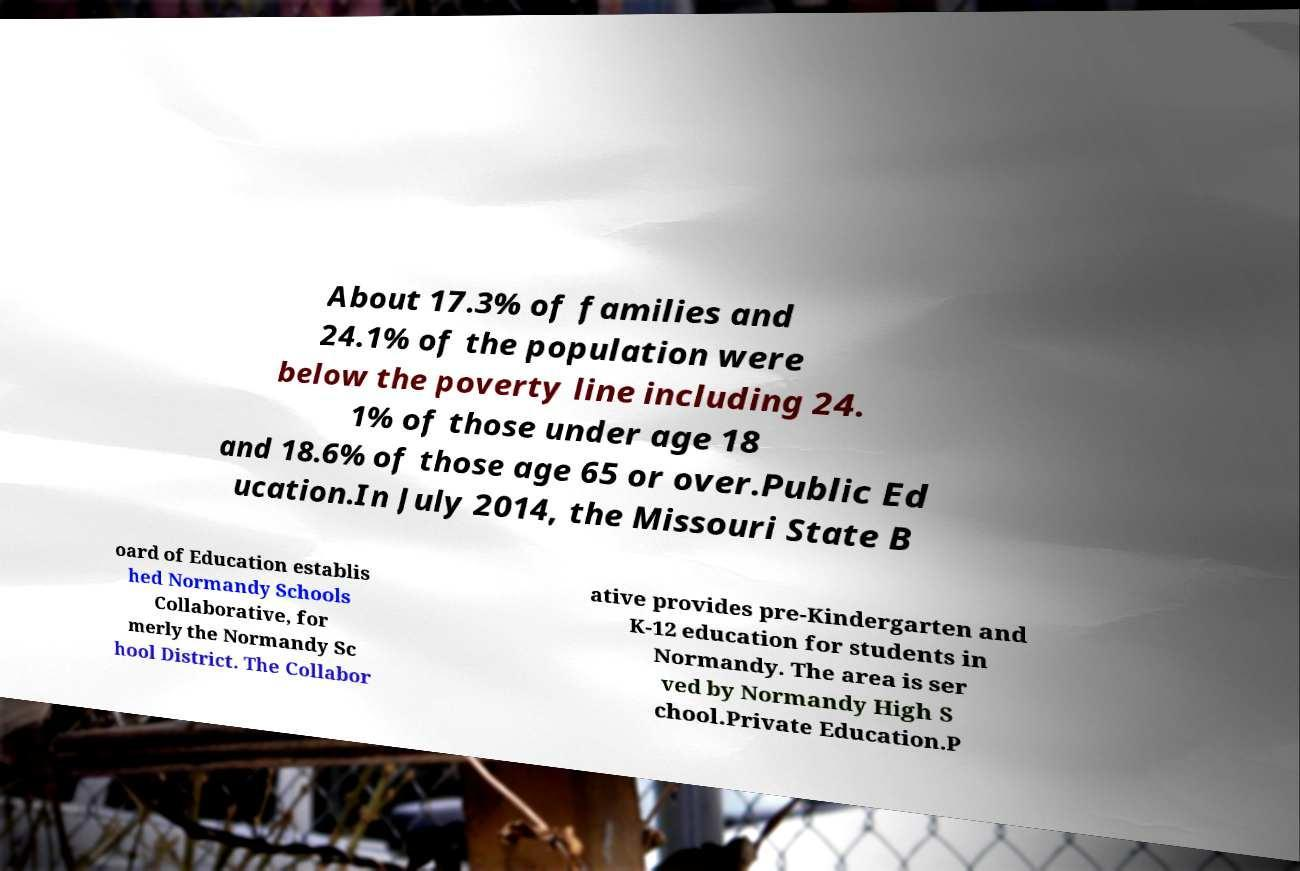What messages or text are displayed in this image? I need them in a readable, typed format. About 17.3% of families and 24.1% of the population were below the poverty line including 24. 1% of those under age 18 and 18.6% of those age 65 or over.Public Ed ucation.In July 2014, the Missouri State B oard of Education establis hed Normandy Schools Collaborative, for merly the Normandy Sc hool District. The Collabor ative provides pre-Kindergarten and K-12 education for students in Normandy. The area is ser ved by Normandy High S chool.Private Education.P 